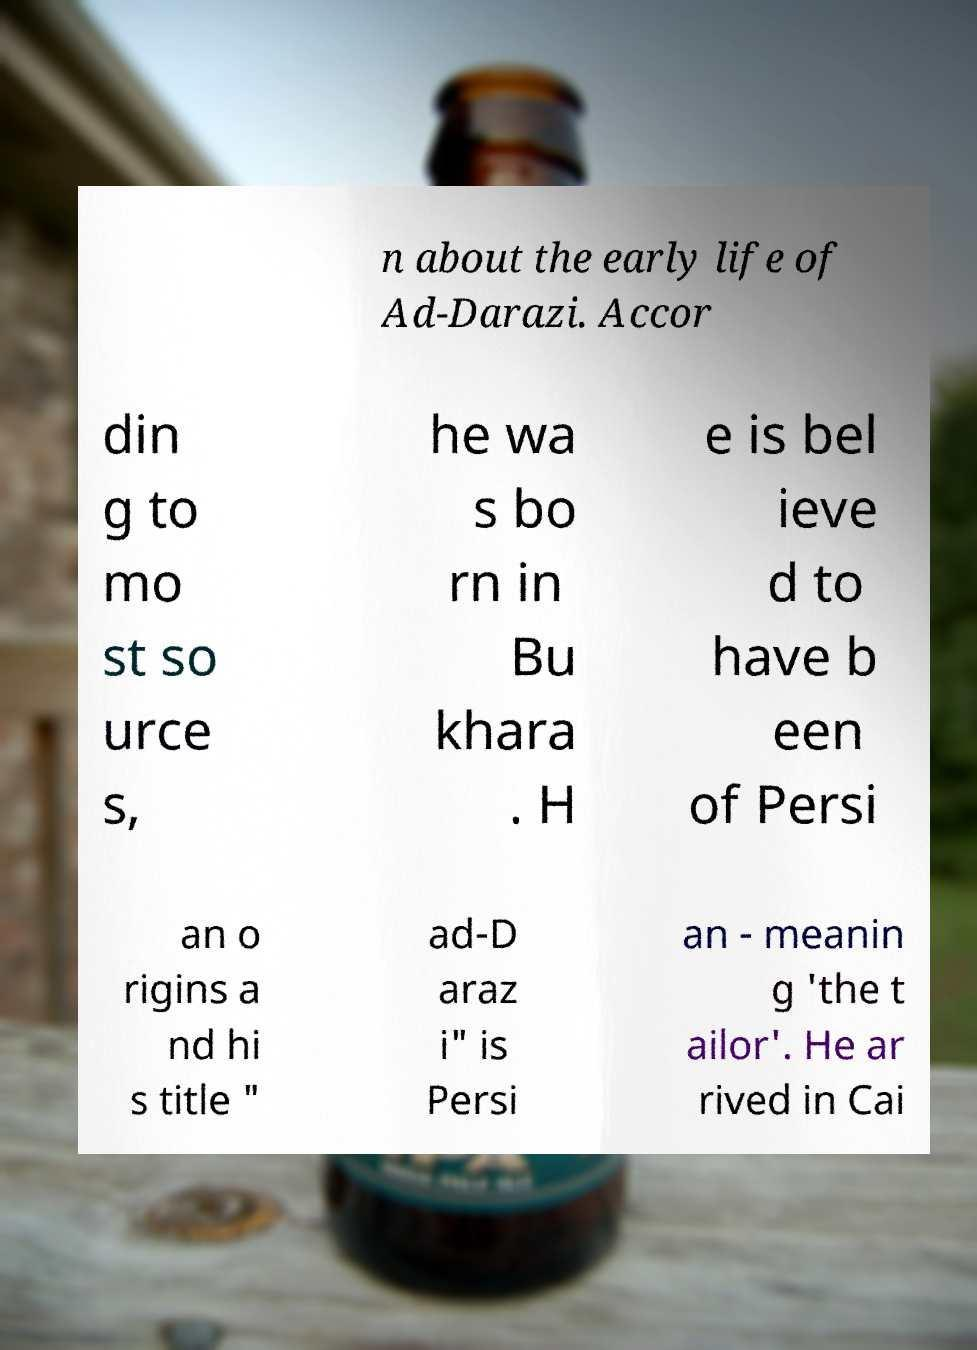Please read and relay the text visible in this image. What does it say? n about the early life of Ad-Darazi. Accor din g to mo st so urce s, he wa s bo rn in Bu khara . H e is bel ieve d to have b een of Persi an o rigins a nd hi s title " ad-D araz i" is Persi an - meanin g 'the t ailor'. He ar rived in Cai 